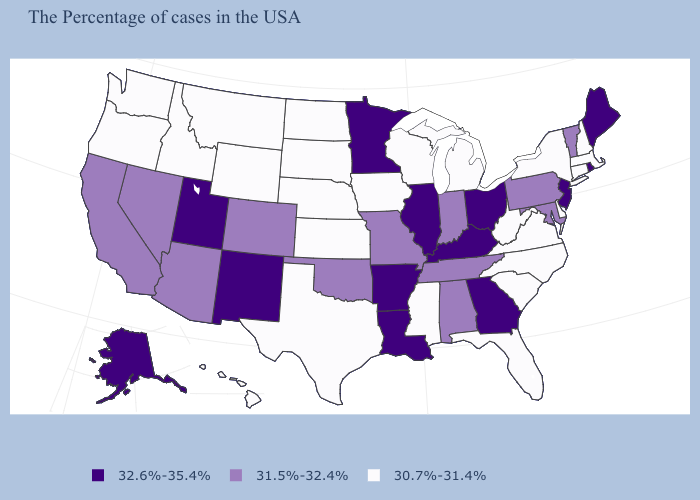What is the value of Louisiana?
Be succinct. 32.6%-35.4%. Name the states that have a value in the range 32.6%-35.4%?
Write a very short answer. Maine, Rhode Island, New Jersey, Ohio, Georgia, Kentucky, Illinois, Louisiana, Arkansas, Minnesota, New Mexico, Utah, Alaska. What is the lowest value in the USA?
Write a very short answer. 30.7%-31.4%. Is the legend a continuous bar?
Keep it brief. No. Which states have the highest value in the USA?
Write a very short answer. Maine, Rhode Island, New Jersey, Ohio, Georgia, Kentucky, Illinois, Louisiana, Arkansas, Minnesota, New Mexico, Utah, Alaska. Name the states that have a value in the range 32.6%-35.4%?
Answer briefly. Maine, Rhode Island, New Jersey, Ohio, Georgia, Kentucky, Illinois, Louisiana, Arkansas, Minnesota, New Mexico, Utah, Alaska. What is the value of Vermont?
Write a very short answer. 31.5%-32.4%. Does Delaware have the lowest value in the South?
Write a very short answer. Yes. Among the states that border Louisiana , does Arkansas have the lowest value?
Answer briefly. No. What is the value of Colorado?
Be succinct. 31.5%-32.4%. Name the states that have a value in the range 32.6%-35.4%?
Answer briefly. Maine, Rhode Island, New Jersey, Ohio, Georgia, Kentucky, Illinois, Louisiana, Arkansas, Minnesota, New Mexico, Utah, Alaska. Which states hav the highest value in the Northeast?
Concise answer only. Maine, Rhode Island, New Jersey. What is the lowest value in states that border Utah?
Short answer required. 30.7%-31.4%. Among the states that border Wisconsin , which have the highest value?
Quick response, please. Illinois, Minnesota. What is the value of North Dakota?
Concise answer only. 30.7%-31.4%. 